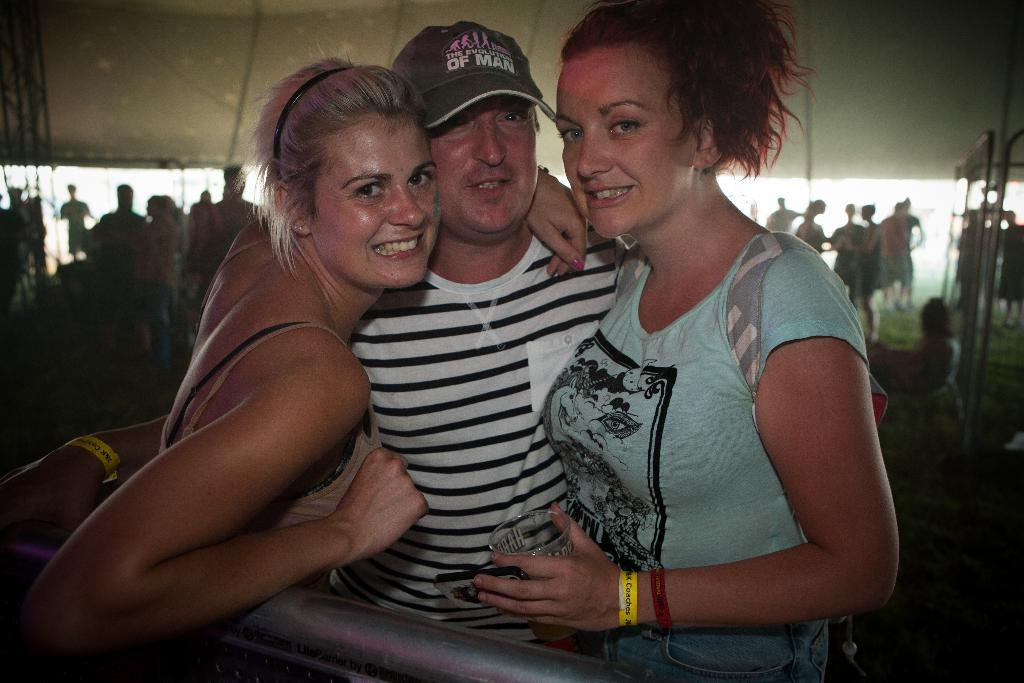How many people are in the image? There are three people in the image: one man and two women. What are the people in the front doing? The man and women are standing and smiling in the front. Can you describe the people in the background? The people in the background appear blurry. What type of spade is the daughter using in the image? There is no daughter or spade present in the image. How many times does the man smash the ball in the image? There is no ball or smashing activity present in the image. 